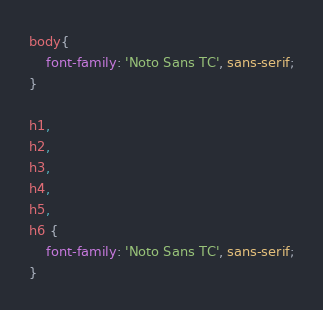Convert code to text. <code><loc_0><loc_0><loc_500><loc_500><_CSS_>body{
	font-family: 'Noto Sans TC', sans-serif;
}

h1,
h2,
h3,
h4,
h5,
h6 {
	font-family: 'Noto Sans TC', sans-serif;
}</code> 